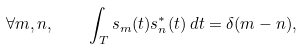Convert formula to latex. <formula><loc_0><loc_0><loc_500><loc_500>\forall m , n , \quad \int _ { T } s _ { m } ( t ) s ^ { * } _ { n } ( t ) \, d t = \delta ( m - n ) ,</formula> 